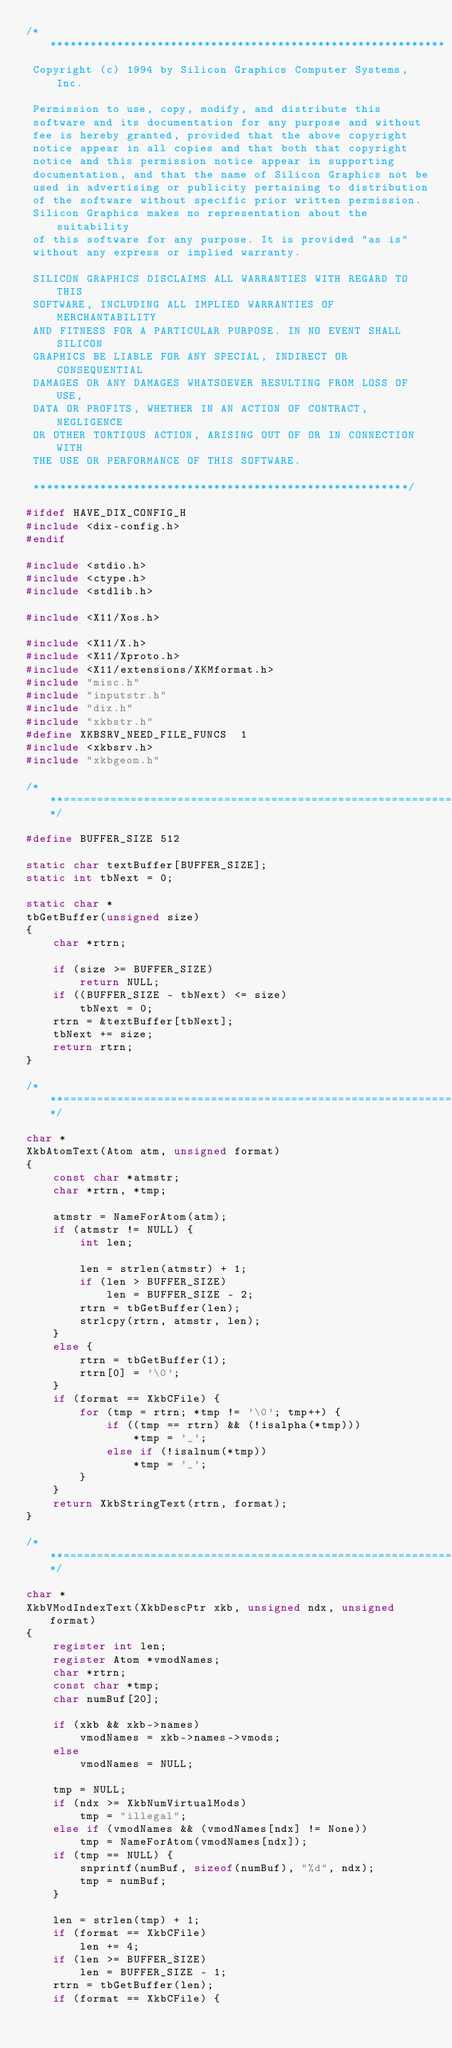Convert code to text. <code><loc_0><loc_0><loc_500><loc_500><_C_>/************************************************************
 Copyright (c) 1994 by Silicon Graphics Computer Systems, Inc.

 Permission to use, copy, modify, and distribute this
 software and its documentation for any purpose and without
 fee is hereby granted, provided that the above copyright
 notice appear in all copies and that both that copyright
 notice and this permission notice appear in supporting
 documentation, and that the name of Silicon Graphics not be
 used in advertising or publicity pertaining to distribution
 of the software without specific prior written permission.
 Silicon Graphics makes no representation about the suitability
 of this software for any purpose. It is provided "as is"
 without any express or implied warranty.

 SILICON GRAPHICS DISCLAIMS ALL WARRANTIES WITH REGARD TO THIS
 SOFTWARE, INCLUDING ALL IMPLIED WARRANTIES OF MERCHANTABILITY
 AND FITNESS FOR A PARTICULAR PURPOSE. IN NO EVENT SHALL SILICON
 GRAPHICS BE LIABLE FOR ANY SPECIAL, INDIRECT OR CONSEQUENTIAL
 DAMAGES OR ANY DAMAGES WHATSOEVER RESULTING FROM LOSS OF USE,
 DATA OR PROFITS, WHETHER IN AN ACTION OF CONTRACT, NEGLIGENCE
 OR OTHER TORTIOUS ACTION, ARISING OUT OF OR IN CONNECTION  WITH
 THE USE OR PERFORMANCE OF THIS SOFTWARE.

 ********************************************************/

#ifdef HAVE_DIX_CONFIG_H
#include <dix-config.h>
#endif

#include <stdio.h>
#include <ctype.h>
#include <stdlib.h>

#include <X11/Xos.h>

#include <X11/X.h>
#include <X11/Xproto.h>
#include <X11/extensions/XKMformat.h>
#include "misc.h"
#include "inputstr.h"
#include "dix.h"
#include "xkbstr.h"
#define XKBSRV_NEED_FILE_FUNCS	1
#include <xkbsrv.h>
#include "xkbgeom.h"

/***====================================================================***/

#define	BUFFER_SIZE	512

static char textBuffer[BUFFER_SIZE];
static int tbNext = 0;

static char *
tbGetBuffer(unsigned size)
{
    char *rtrn;

    if (size >= BUFFER_SIZE)
        return NULL;
    if ((BUFFER_SIZE - tbNext) <= size)
        tbNext = 0;
    rtrn = &textBuffer[tbNext];
    tbNext += size;
    return rtrn;
}

/***====================================================================***/

char *
XkbAtomText(Atom atm, unsigned format)
{
    const char *atmstr;
    char *rtrn, *tmp;

    atmstr = NameForAtom(atm);
    if (atmstr != NULL) {
        int len;

        len = strlen(atmstr) + 1;
        if (len > BUFFER_SIZE)
            len = BUFFER_SIZE - 2;
        rtrn = tbGetBuffer(len);
        strlcpy(rtrn, atmstr, len);
    }
    else {
        rtrn = tbGetBuffer(1);
        rtrn[0] = '\0';
    }
    if (format == XkbCFile) {
        for (tmp = rtrn; *tmp != '\0'; tmp++) {
            if ((tmp == rtrn) && (!isalpha(*tmp)))
                *tmp = '_';
            else if (!isalnum(*tmp))
                *tmp = '_';
        }
    }
    return XkbStringText(rtrn, format);
}

/***====================================================================***/

char *
XkbVModIndexText(XkbDescPtr xkb, unsigned ndx, unsigned format)
{
    register int len;
    register Atom *vmodNames;
    char *rtrn;
    const char *tmp;
    char numBuf[20];

    if (xkb && xkb->names)
        vmodNames = xkb->names->vmods;
    else
        vmodNames = NULL;

    tmp = NULL;
    if (ndx >= XkbNumVirtualMods)
        tmp = "illegal";
    else if (vmodNames && (vmodNames[ndx] != None))
        tmp = NameForAtom(vmodNames[ndx]);
    if (tmp == NULL) {
        snprintf(numBuf, sizeof(numBuf), "%d", ndx);
        tmp = numBuf;
    }

    len = strlen(tmp) + 1;
    if (format == XkbCFile)
        len += 4;
    if (len >= BUFFER_SIZE)
        len = BUFFER_SIZE - 1;
    rtrn = tbGetBuffer(len);
    if (format == XkbCFile) {</code> 